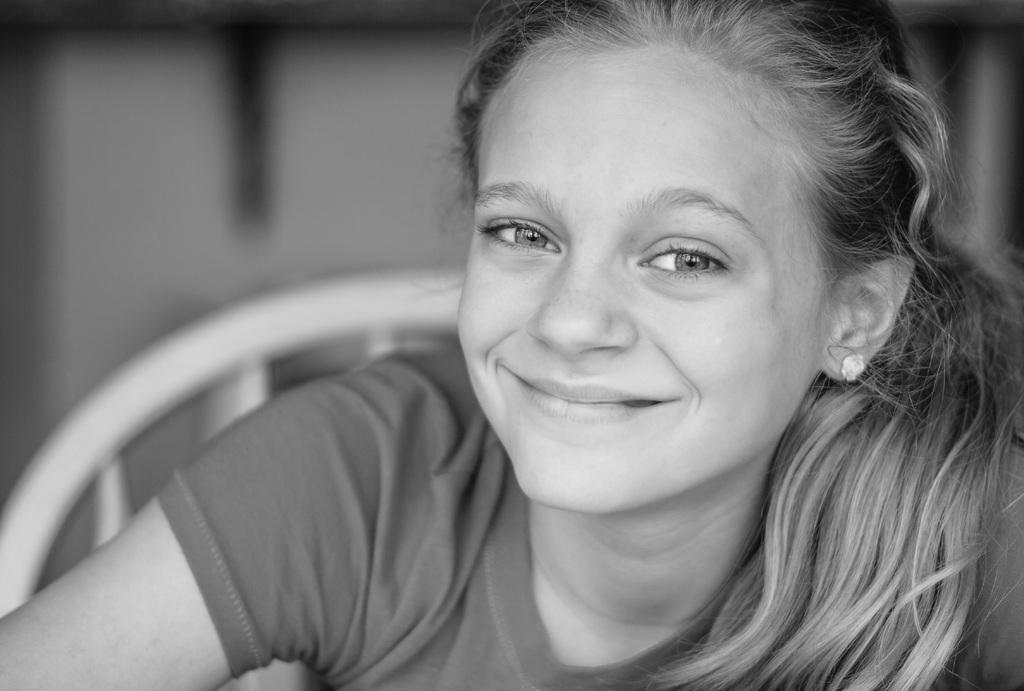What is the main subject in the foreground of the image? There is a person sitting on a chair in the foreground of the image. Can you describe the background of the image? The background of the image appears blurry. What type of sack can be seen floating on the lake in the background of the image? There is no lake or sack present in the image; the background appears blurry. 